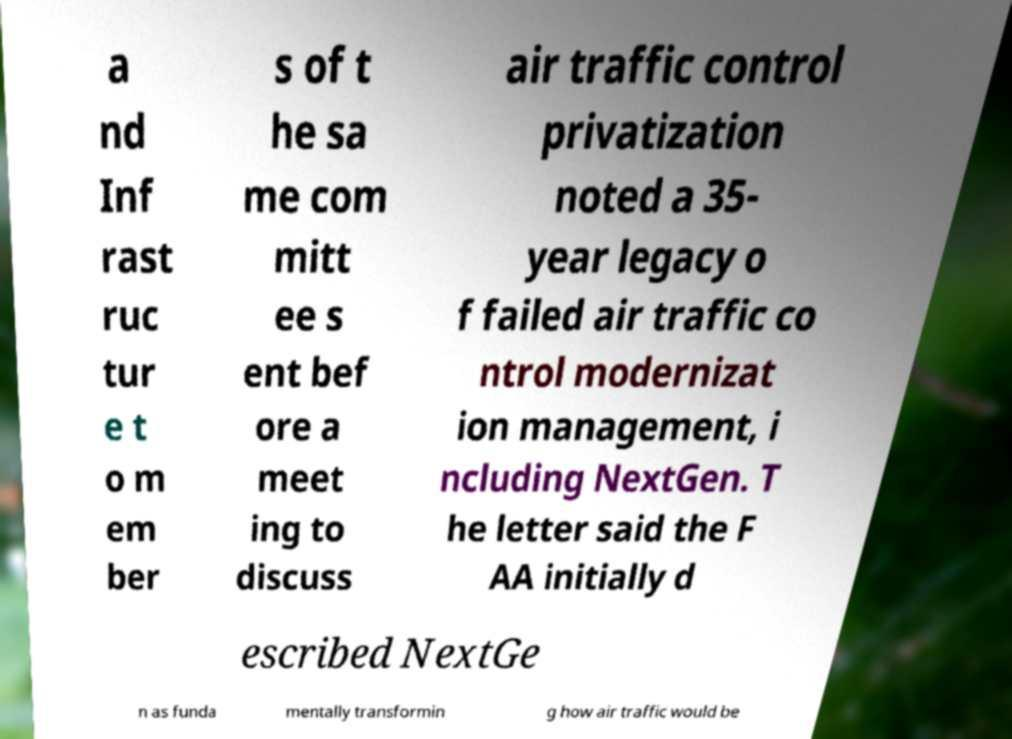Please read and relay the text visible in this image. What does it say? a nd Inf rast ruc tur e t o m em ber s of t he sa me com mitt ee s ent bef ore a meet ing to discuss air traffic control privatization noted a 35- year legacy o f failed air traffic co ntrol modernizat ion management, i ncluding NextGen. T he letter said the F AA initially d escribed NextGe n as funda mentally transformin g how air traffic would be 